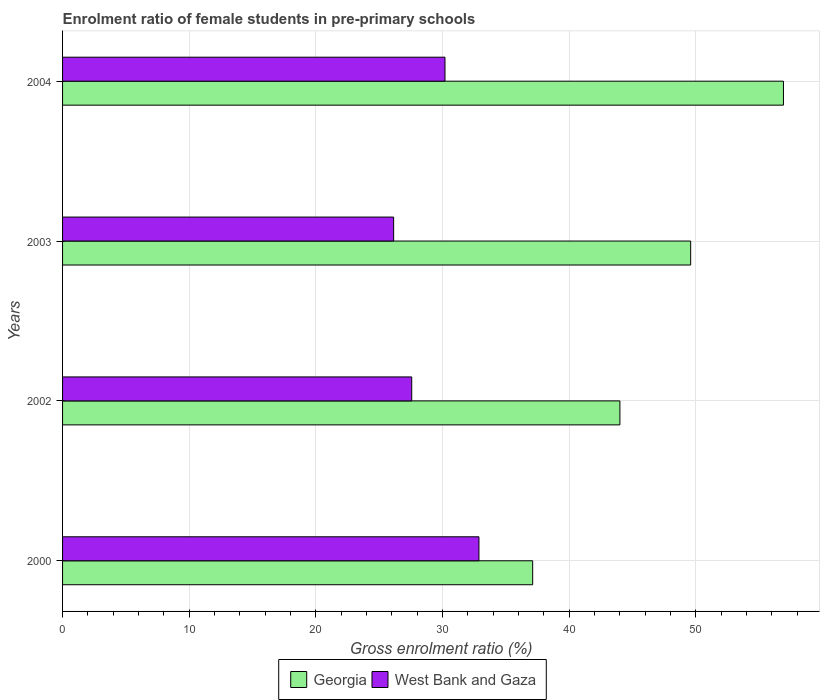Are the number of bars on each tick of the Y-axis equal?
Ensure brevity in your answer.  Yes. How many bars are there on the 1st tick from the top?
Keep it short and to the point. 2. What is the label of the 4th group of bars from the top?
Give a very brief answer. 2000. In how many cases, is the number of bars for a given year not equal to the number of legend labels?
Ensure brevity in your answer.  0. What is the enrolment ratio of female students in pre-primary schools in Georgia in 2004?
Offer a terse response. 56.91. Across all years, what is the maximum enrolment ratio of female students in pre-primary schools in Georgia?
Your response must be concise. 56.91. Across all years, what is the minimum enrolment ratio of female students in pre-primary schools in Georgia?
Make the answer very short. 37.11. In which year was the enrolment ratio of female students in pre-primary schools in Georgia maximum?
Give a very brief answer. 2004. In which year was the enrolment ratio of female students in pre-primary schools in West Bank and Gaza minimum?
Make the answer very short. 2003. What is the total enrolment ratio of female students in pre-primary schools in Georgia in the graph?
Offer a terse response. 187.6. What is the difference between the enrolment ratio of female students in pre-primary schools in West Bank and Gaza in 2000 and that in 2003?
Give a very brief answer. 6.73. What is the difference between the enrolment ratio of female students in pre-primary schools in Georgia in 2000 and the enrolment ratio of female students in pre-primary schools in West Bank and Gaza in 2002?
Keep it short and to the point. 9.55. What is the average enrolment ratio of female students in pre-primary schools in Georgia per year?
Your answer should be very brief. 46.9. In the year 2002, what is the difference between the enrolment ratio of female students in pre-primary schools in Georgia and enrolment ratio of female students in pre-primary schools in West Bank and Gaza?
Keep it short and to the point. 16.44. What is the ratio of the enrolment ratio of female students in pre-primary schools in Georgia in 2000 to that in 2004?
Keep it short and to the point. 0.65. What is the difference between the highest and the second highest enrolment ratio of female students in pre-primary schools in West Bank and Gaza?
Offer a very short reply. 2.68. What is the difference between the highest and the lowest enrolment ratio of female students in pre-primary schools in West Bank and Gaza?
Your answer should be compact. 6.73. In how many years, is the enrolment ratio of female students in pre-primary schools in Georgia greater than the average enrolment ratio of female students in pre-primary schools in Georgia taken over all years?
Your answer should be very brief. 2. What does the 1st bar from the top in 2004 represents?
Ensure brevity in your answer.  West Bank and Gaza. What does the 1st bar from the bottom in 2000 represents?
Provide a succinct answer. Georgia. How many years are there in the graph?
Give a very brief answer. 4. Does the graph contain grids?
Offer a terse response. Yes. How are the legend labels stacked?
Your answer should be compact. Horizontal. What is the title of the graph?
Offer a very short reply. Enrolment ratio of female students in pre-primary schools. What is the label or title of the Y-axis?
Make the answer very short. Years. What is the Gross enrolment ratio (%) of Georgia in 2000?
Ensure brevity in your answer.  37.11. What is the Gross enrolment ratio (%) of West Bank and Gaza in 2000?
Make the answer very short. 32.87. What is the Gross enrolment ratio (%) of Georgia in 2002?
Give a very brief answer. 44. What is the Gross enrolment ratio (%) of West Bank and Gaza in 2002?
Offer a very short reply. 27.56. What is the Gross enrolment ratio (%) of Georgia in 2003?
Make the answer very short. 49.58. What is the Gross enrolment ratio (%) in West Bank and Gaza in 2003?
Ensure brevity in your answer.  26.14. What is the Gross enrolment ratio (%) of Georgia in 2004?
Your answer should be compact. 56.91. What is the Gross enrolment ratio (%) in West Bank and Gaza in 2004?
Provide a succinct answer. 30.19. Across all years, what is the maximum Gross enrolment ratio (%) of Georgia?
Provide a succinct answer. 56.91. Across all years, what is the maximum Gross enrolment ratio (%) in West Bank and Gaza?
Provide a short and direct response. 32.87. Across all years, what is the minimum Gross enrolment ratio (%) of Georgia?
Provide a succinct answer. 37.11. Across all years, what is the minimum Gross enrolment ratio (%) in West Bank and Gaza?
Provide a succinct answer. 26.14. What is the total Gross enrolment ratio (%) of Georgia in the graph?
Provide a succinct answer. 187.6. What is the total Gross enrolment ratio (%) of West Bank and Gaza in the graph?
Keep it short and to the point. 116.75. What is the difference between the Gross enrolment ratio (%) in Georgia in 2000 and that in 2002?
Provide a succinct answer. -6.89. What is the difference between the Gross enrolment ratio (%) of West Bank and Gaza in 2000 and that in 2002?
Keep it short and to the point. 5.31. What is the difference between the Gross enrolment ratio (%) in Georgia in 2000 and that in 2003?
Provide a short and direct response. -12.47. What is the difference between the Gross enrolment ratio (%) in West Bank and Gaza in 2000 and that in 2003?
Your response must be concise. 6.73. What is the difference between the Gross enrolment ratio (%) in Georgia in 2000 and that in 2004?
Provide a short and direct response. -19.8. What is the difference between the Gross enrolment ratio (%) in West Bank and Gaza in 2000 and that in 2004?
Give a very brief answer. 2.68. What is the difference between the Gross enrolment ratio (%) in Georgia in 2002 and that in 2003?
Give a very brief answer. -5.59. What is the difference between the Gross enrolment ratio (%) of West Bank and Gaza in 2002 and that in 2003?
Provide a succinct answer. 1.43. What is the difference between the Gross enrolment ratio (%) of Georgia in 2002 and that in 2004?
Keep it short and to the point. -12.91. What is the difference between the Gross enrolment ratio (%) of West Bank and Gaza in 2002 and that in 2004?
Make the answer very short. -2.63. What is the difference between the Gross enrolment ratio (%) in Georgia in 2003 and that in 2004?
Ensure brevity in your answer.  -7.32. What is the difference between the Gross enrolment ratio (%) in West Bank and Gaza in 2003 and that in 2004?
Your response must be concise. -4.05. What is the difference between the Gross enrolment ratio (%) in Georgia in 2000 and the Gross enrolment ratio (%) in West Bank and Gaza in 2002?
Offer a very short reply. 9.55. What is the difference between the Gross enrolment ratio (%) of Georgia in 2000 and the Gross enrolment ratio (%) of West Bank and Gaza in 2003?
Offer a very short reply. 10.98. What is the difference between the Gross enrolment ratio (%) in Georgia in 2000 and the Gross enrolment ratio (%) in West Bank and Gaza in 2004?
Provide a succinct answer. 6.92. What is the difference between the Gross enrolment ratio (%) in Georgia in 2002 and the Gross enrolment ratio (%) in West Bank and Gaza in 2003?
Offer a very short reply. 17.86. What is the difference between the Gross enrolment ratio (%) of Georgia in 2002 and the Gross enrolment ratio (%) of West Bank and Gaza in 2004?
Provide a short and direct response. 13.81. What is the difference between the Gross enrolment ratio (%) in Georgia in 2003 and the Gross enrolment ratio (%) in West Bank and Gaza in 2004?
Your answer should be compact. 19.4. What is the average Gross enrolment ratio (%) in Georgia per year?
Make the answer very short. 46.9. What is the average Gross enrolment ratio (%) in West Bank and Gaza per year?
Ensure brevity in your answer.  29.19. In the year 2000, what is the difference between the Gross enrolment ratio (%) in Georgia and Gross enrolment ratio (%) in West Bank and Gaza?
Give a very brief answer. 4.24. In the year 2002, what is the difference between the Gross enrolment ratio (%) of Georgia and Gross enrolment ratio (%) of West Bank and Gaza?
Keep it short and to the point. 16.44. In the year 2003, what is the difference between the Gross enrolment ratio (%) of Georgia and Gross enrolment ratio (%) of West Bank and Gaza?
Offer a very short reply. 23.45. In the year 2004, what is the difference between the Gross enrolment ratio (%) of Georgia and Gross enrolment ratio (%) of West Bank and Gaza?
Make the answer very short. 26.72. What is the ratio of the Gross enrolment ratio (%) of Georgia in 2000 to that in 2002?
Offer a terse response. 0.84. What is the ratio of the Gross enrolment ratio (%) in West Bank and Gaza in 2000 to that in 2002?
Provide a short and direct response. 1.19. What is the ratio of the Gross enrolment ratio (%) of Georgia in 2000 to that in 2003?
Offer a very short reply. 0.75. What is the ratio of the Gross enrolment ratio (%) of West Bank and Gaza in 2000 to that in 2003?
Ensure brevity in your answer.  1.26. What is the ratio of the Gross enrolment ratio (%) in Georgia in 2000 to that in 2004?
Keep it short and to the point. 0.65. What is the ratio of the Gross enrolment ratio (%) in West Bank and Gaza in 2000 to that in 2004?
Offer a very short reply. 1.09. What is the ratio of the Gross enrolment ratio (%) in Georgia in 2002 to that in 2003?
Give a very brief answer. 0.89. What is the ratio of the Gross enrolment ratio (%) in West Bank and Gaza in 2002 to that in 2003?
Offer a terse response. 1.05. What is the ratio of the Gross enrolment ratio (%) in Georgia in 2002 to that in 2004?
Make the answer very short. 0.77. What is the ratio of the Gross enrolment ratio (%) of West Bank and Gaza in 2002 to that in 2004?
Provide a short and direct response. 0.91. What is the ratio of the Gross enrolment ratio (%) of Georgia in 2003 to that in 2004?
Offer a terse response. 0.87. What is the ratio of the Gross enrolment ratio (%) in West Bank and Gaza in 2003 to that in 2004?
Offer a terse response. 0.87. What is the difference between the highest and the second highest Gross enrolment ratio (%) of Georgia?
Keep it short and to the point. 7.32. What is the difference between the highest and the second highest Gross enrolment ratio (%) of West Bank and Gaza?
Offer a terse response. 2.68. What is the difference between the highest and the lowest Gross enrolment ratio (%) in Georgia?
Your answer should be very brief. 19.8. What is the difference between the highest and the lowest Gross enrolment ratio (%) of West Bank and Gaza?
Make the answer very short. 6.73. 